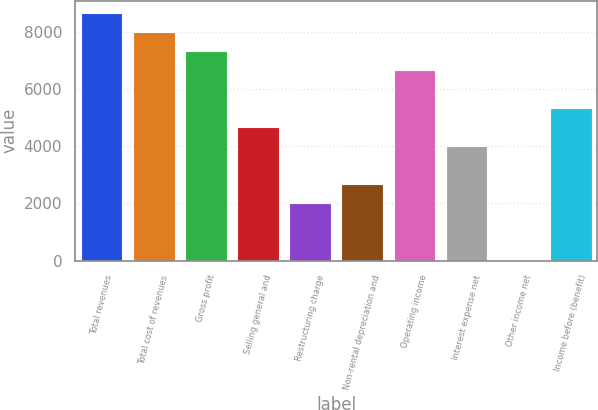Convert chart. <chart><loc_0><loc_0><loc_500><loc_500><bar_chart><fcel>Total revenues<fcel>Total cost of revenues<fcel>Gross profit<fcel>Selling general and<fcel>Restructuring charge<fcel>Non-rental depreciation and<fcel>Operating income<fcel>Interest expense net<fcel>Other income net<fcel>Income before (benefit)<nl><fcel>8631.8<fcel>7968.2<fcel>7304.6<fcel>4650.2<fcel>1995.8<fcel>2659.4<fcel>6641<fcel>3986.6<fcel>5<fcel>5313.8<nl></chart> 